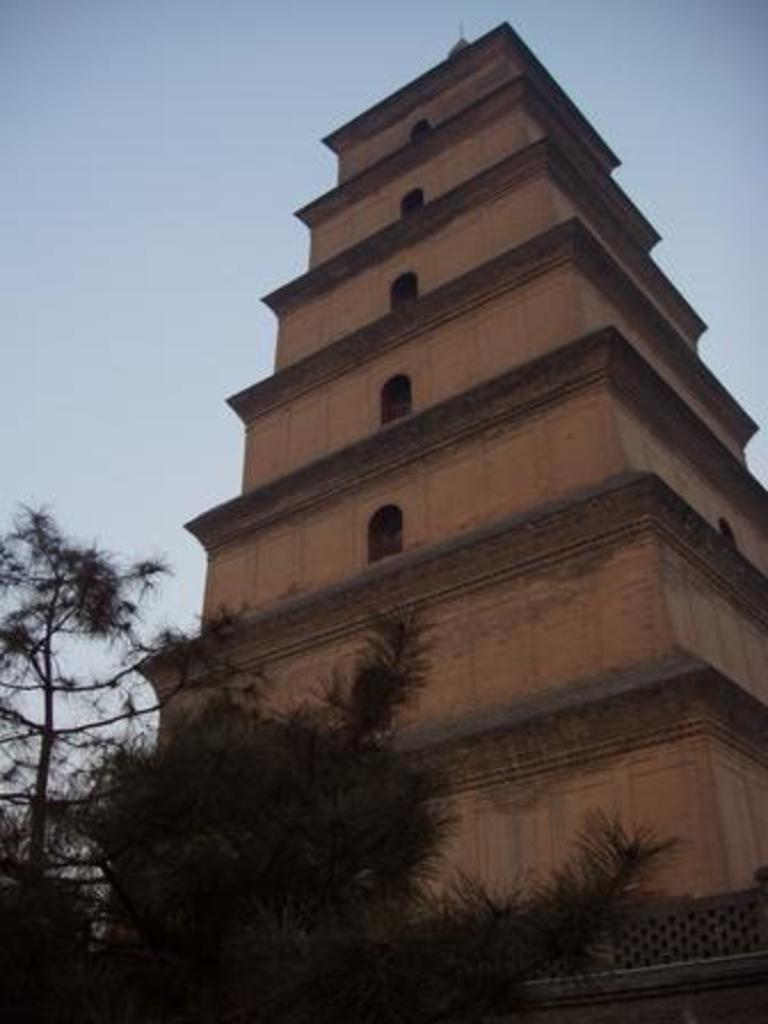Describe this image in one or two sentences. This image consists of a building. At the bottom, there are trees. At the top, there is sky. 